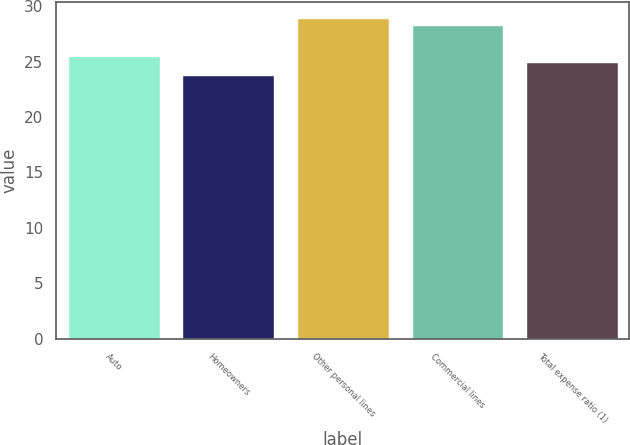Convert chart to OTSL. <chart><loc_0><loc_0><loc_500><loc_500><bar_chart><fcel>Auto<fcel>Homeowners<fcel>Other personal lines<fcel>Commercial lines<fcel>Total expense ratio (1)<nl><fcel>25.51<fcel>23.8<fcel>28.9<fcel>28.3<fcel>25<nl></chart> 